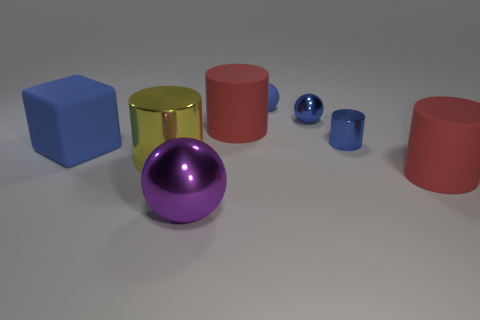What is the material of the tiny object that is the same shape as the large yellow thing?
Ensure brevity in your answer.  Metal. Is the color of the tiny cylinder the same as the tiny shiny sphere?
Offer a terse response. Yes. The big red matte thing behind the large matte cylinder to the right of the tiny rubber ball is what shape?
Give a very brief answer. Cylinder. The large yellow object that is the same material as the purple object is what shape?
Your answer should be compact. Cylinder. What number of other objects are the same shape as the small matte thing?
Your answer should be very brief. 2. There is a blue block to the left of the purple metallic thing; does it have the same size as the yellow metal cylinder?
Provide a short and direct response. Yes. Are there more blue matte balls in front of the small blue rubber sphere than blue blocks?
Your answer should be very brief. No. What number of big yellow metal cylinders are in front of the big purple metal ball that is right of the large shiny cylinder?
Your answer should be very brief. 0. Are there fewer big matte objects that are in front of the purple metal object than tiny green shiny spheres?
Your response must be concise. No. There is a big red rubber cylinder on the left side of the red thing that is in front of the large yellow cylinder; is there a blue shiny thing left of it?
Your answer should be compact. No. 